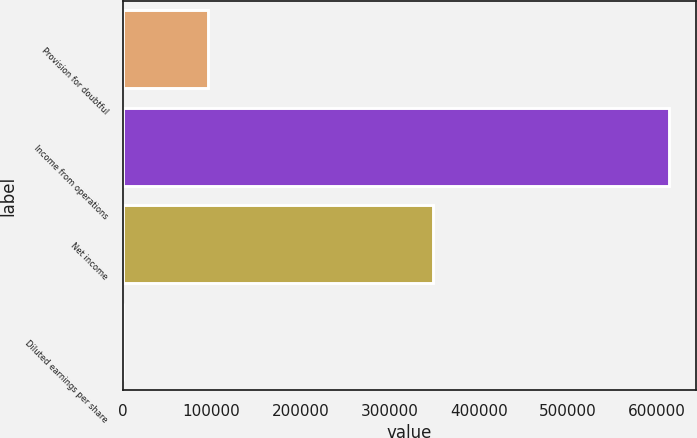<chart> <loc_0><loc_0><loc_500><loc_500><bar_chart><fcel>Provision for doubtful<fcel>Income from operations<fcel>Net income<fcel>Diluted earnings per share<nl><fcel>96461<fcel>613180<fcel>348251<fcel>0.25<nl></chart> 